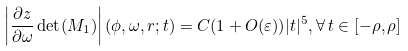Convert formula to latex. <formula><loc_0><loc_0><loc_500><loc_500>\left | \frac { \partial z } { \partial \omega } \det ( M _ { 1 } ) \right | ( \phi , \omega , r ; t ) = C ( 1 + O ( \varepsilon ) ) | t | ^ { 5 } , \forall \, t \in [ - \rho , \rho ]</formula> 